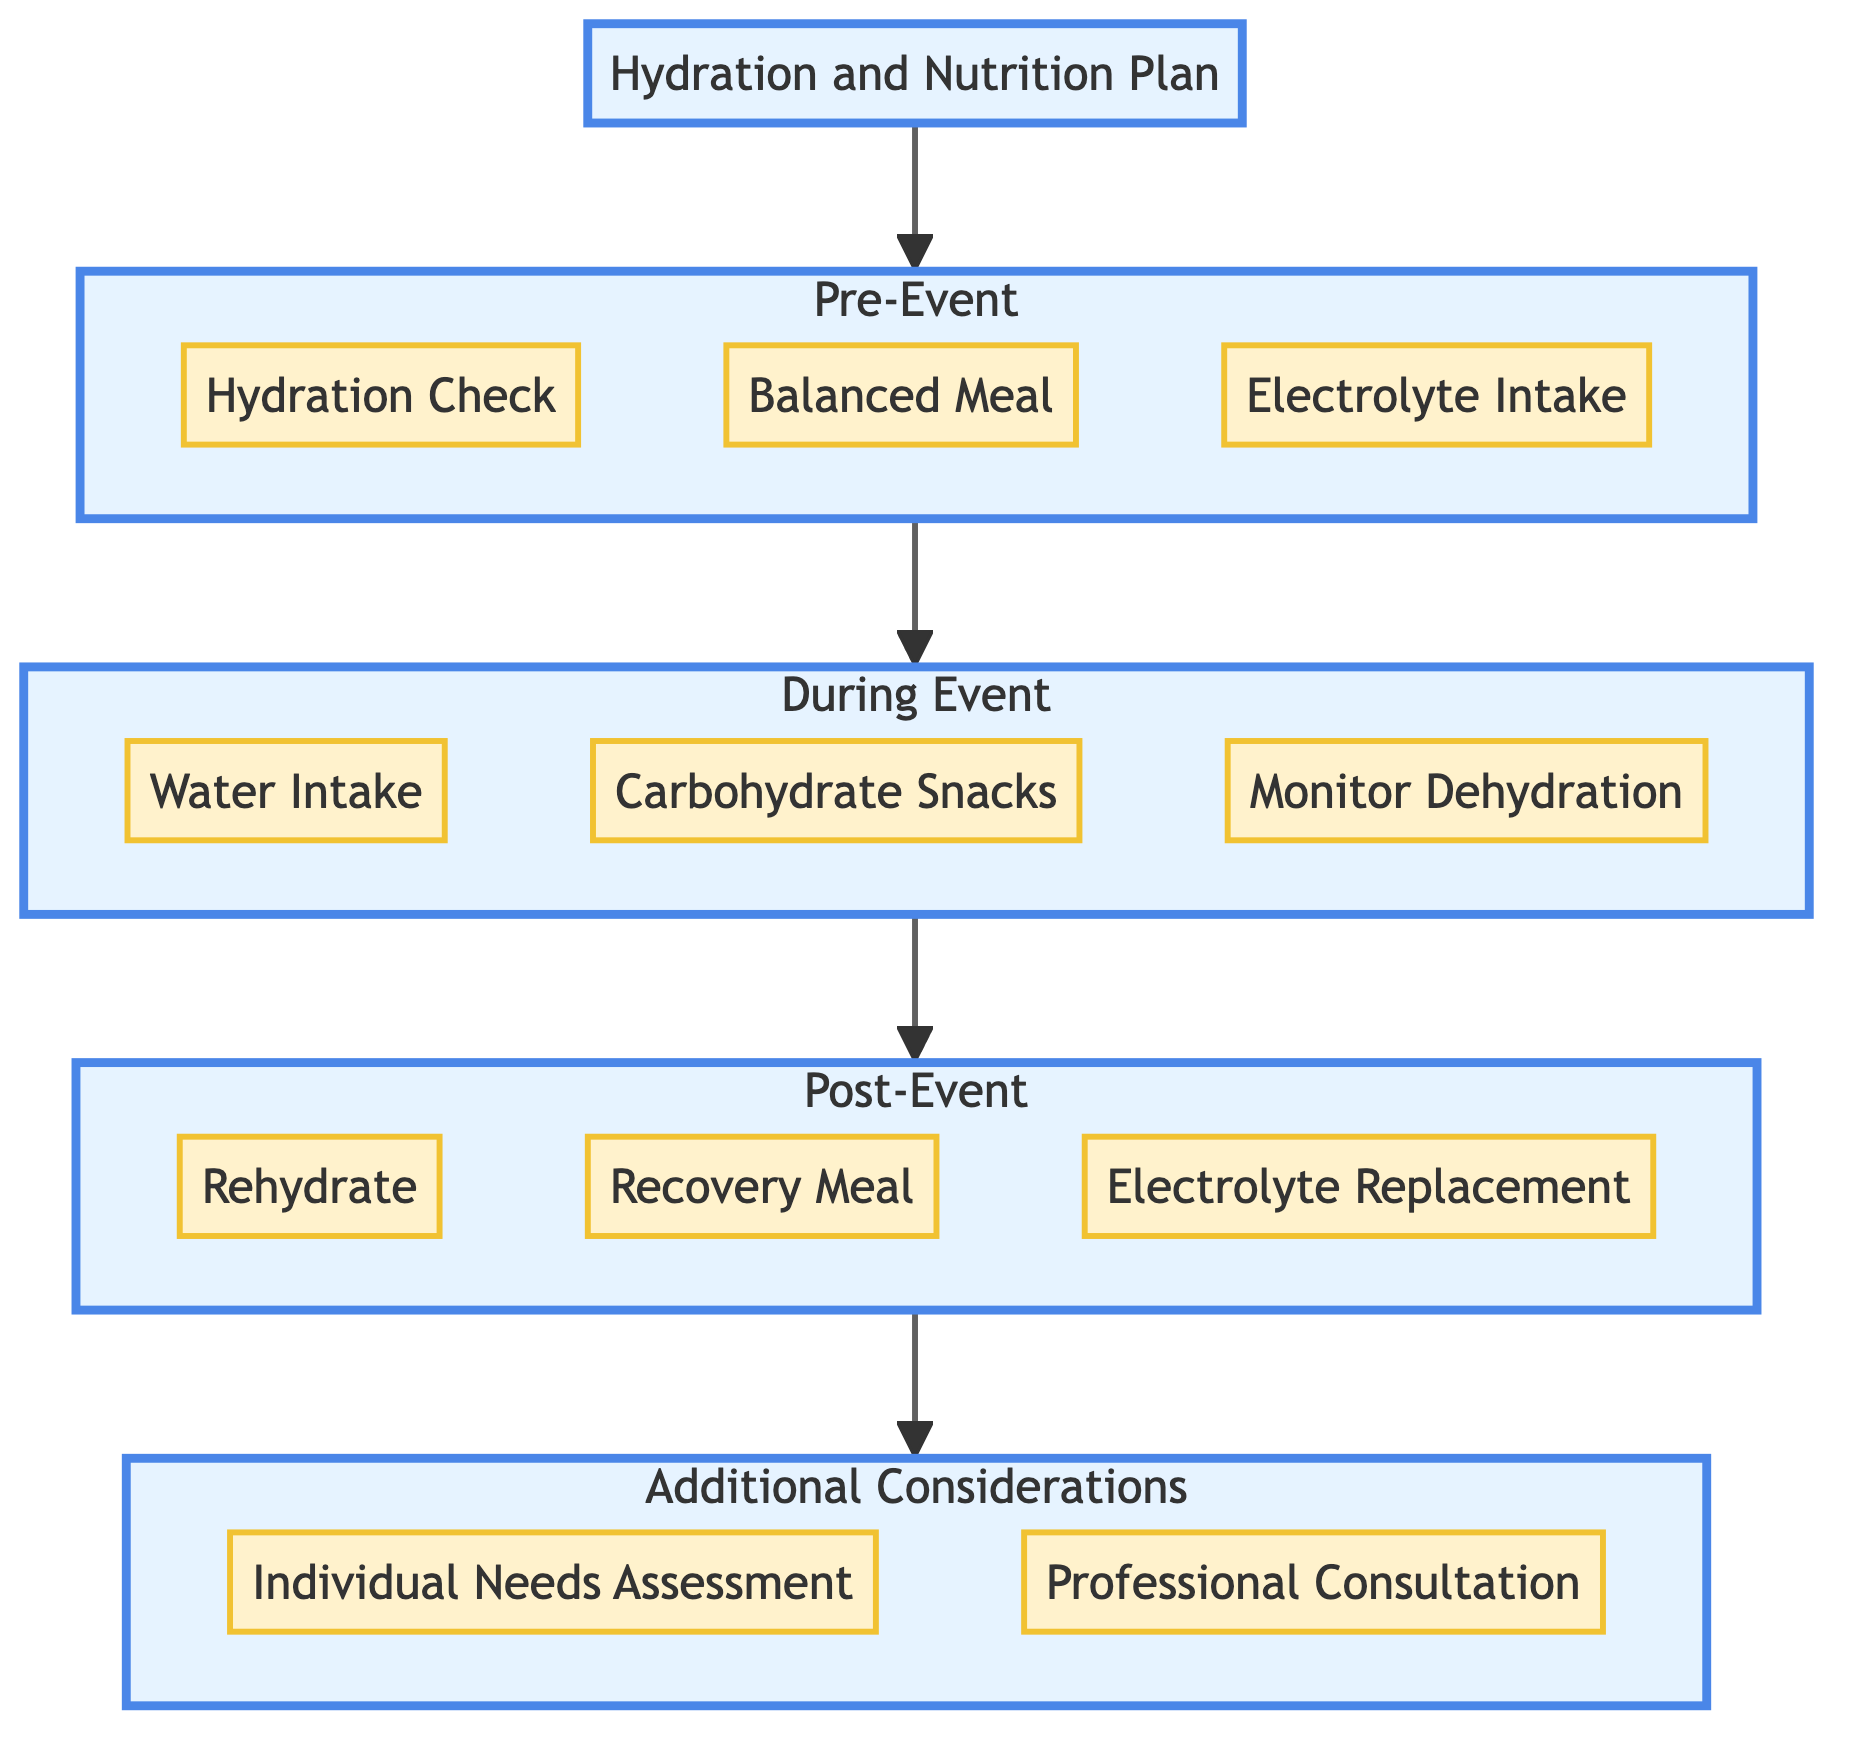What are the three components in the Pre-Event stage? The Pre-Event stage includes "Hydration Check," "Balanced Meal," and "Electrolyte Intake." This can be directly identified from the diagram by looking at the three components listed under the Pre-Event stage.
Answer: Hydration Check, Balanced Meal, Electrolyte Intake How many components are listed in the During Event stage? The During Event stage contains three components: "Water Intake," "Carbohydrate Snacks," and "Monitor Dehydration." Adding these up gives a total of three components in that stage.
Answer: 3 What is the recommended water intake for rehydration after an event? According to the diagram, for rehydration after the event, athletes should drink 16-24 oz of water for each pound lost during the event. This detail is explicitly stated under the Post-Event components.
Answer: 16-24 oz What component comes directly after Balanced Meal in the pathway? The component that comes directly after "Balanced Meal" in the pathway is "Electrolyte Intake." This can be traced from the flow of arrows which connects the components in sequential order.
Answer: Electrolyte Intake What is the purpose of the Individual Needs Assessment component? The purpose of the "Individual Needs Assessment" is to customize the hydration and nutrition plan based on each athlete's body weight, sweat rate, and specific dietary requirements. This interpretation comes from the details outlined in that specific component.
Answer: Customize plan How does the hydration plan proceed from the During Event stage to the Post-Event stage? The pathway flows from "Monitor Signs of Dehydration" in the During Event stage to "Rehydrate" in the Post-Event stage. This reflects that monitoring hydration while competing leads directly into the rehydration aspect after the event concludes.
Answer: Rehydrate What should athletes consume within 30 minutes after the event according to the diagram? Athletes are advised to consume a "Recovery Meal" within 30 minutes of the event completion. This information is found under the Post-Event stage and is explicitly stated in that component.
Answer: Recovery Meal What shows the connection between the Pre-Event and During Event stages? The connection between the Pre-Event stage and the During Event stage is depicted by a solid line or arrow that indicates the flow from one stage to the next. This visual cue represents the logical sequence of actions taken from preparation to execution during the event.
Answer: A solid line/arrow 